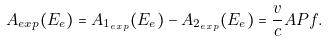<formula> <loc_0><loc_0><loc_500><loc_500>A _ { e x p } ( E _ { e } ) = A _ { 1 _ { e x p } } ( E _ { e } ) - A _ { 2 _ { e x p } } ( E _ { e } ) = \frac { v } { c } A P f .</formula> 